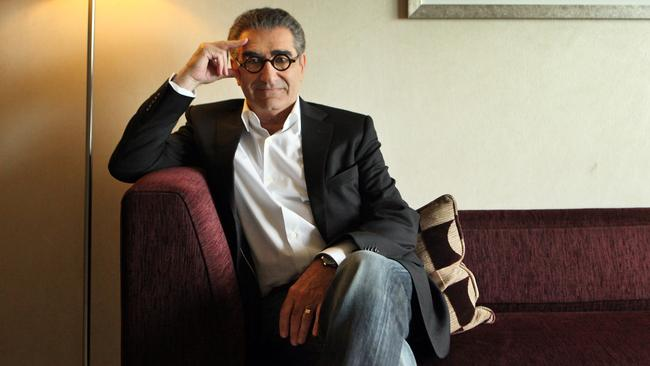Analyze the image in a comprehensive and detailed manner. In the image, we see a distinguished figure, exemplifying a relaxed yet sophisticated demeanor. Seated on a plush, purple couch, the individual's relaxed pose, with legs crossed and hands expressing subtle gestures, adds a contemplative air to the ambiance. His attire, consisting of a sleek black blazer paired with a clean white shirt and casual blue jeans, strikes a balance between formal and informal, suitable for various occasions. Noticeably, his characteristic eyeglasses and thoughtful facial expression, accented by his hand lightly resting on his forehead, convey a moment of introspection. The surroundings feature a minimalist beige wall, complemented by a simple yet elegant framed artwork, enhancing the serene and cultured atmosphere of the setting. 